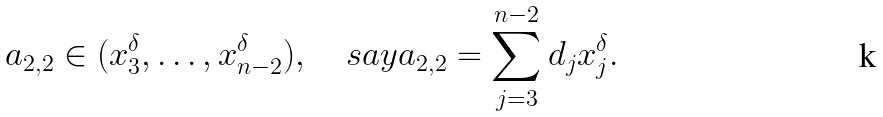<formula> <loc_0><loc_0><loc_500><loc_500>a _ { 2 , 2 } \in ( x _ { 3 } ^ { \delta } , \dots , x _ { n - 2 } ^ { \delta } ) , \quad s a y a _ { 2 , 2 } = \sum _ { j = 3 } ^ { n - 2 } d _ { j } x _ { j } ^ { \delta } .</formula> 